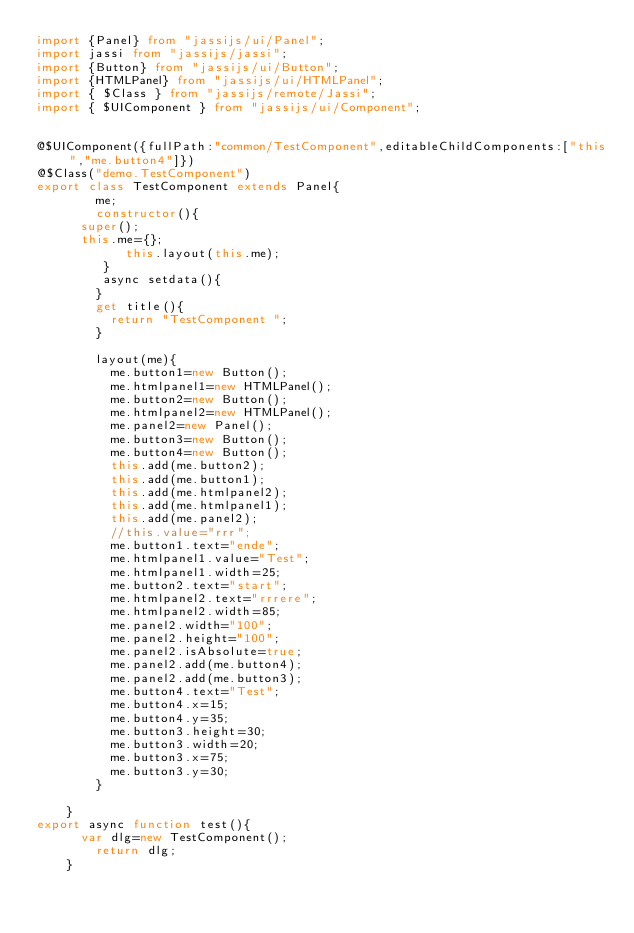<code> <loc_0><loc_0><loc_500><loc_500><_TypeScript_>import {Panel} from "jassijs/ui/Panel";
import jassi from "jassijs/jassi";
import {Button} from "jassijs/ui/Button";
import {HTMLPanel} from "jassijs/ui/HTMLPanel";
import { $Class } from "jassijs/remote/Jassi";
import { $UIComponent } from "jassijs/ui/Component";


@$UIComponent({fullPath:"common/TestComponent",editableChildComponents:["this","me.button4"]})
@$Class("demo.TestComponent")
export class TestComponent extends Panel{
        me;
        constructor(){
			super();
			this.me={};
            this.layout(this.me);
         }
         async setdata(){
        }
        get title(){
        	return "TestComponent ";
        }
      
        layout(me){
        	me.button1=new Button();
        	me.htmlpanel1=new HTMLPanel();
        	me.button2=new Button();
        	me.htmlpanel2=new HTMLPanel();
        	me.panel2=new Panel();
        	me.button3=new Button();
        	me.button4=new Button();
        	this.add(me.button2);
        	this.add(me.button1);
        	this.add(me.htmlpanel2);
        	this.add(me.htmlpanel1);
        	this.add(me.panel2);
        	//this.value="rrr";
        	me.button1.text="ende";
        	me.htmlpanel1.value="Test";
        	me.htmlpanel1.width=25;
        	me.button2.text="start";
        	me.htmlpanel2.text="rrrere";
        	me.htmlpanel2.width=85;
        	me.panel2.width="100";
        	me.panel2.height="100";
        	me.panel2.isAbsolute=true;
        	me.panel2.add(me.button4);
        	me.panel2.add(me.button3);
        	me.button4.text="Test";
        	me.button4.x=15;
        	me.button4.y=35;
        	me.button3.height=30;
        	me.button3.width=20;
        	me.button3.x=75;
        	me.button3.y=30;
        }
      
    }
export async function test(){
    	var dlg=new TestComponent();
        return dlg;
    }

</code> 